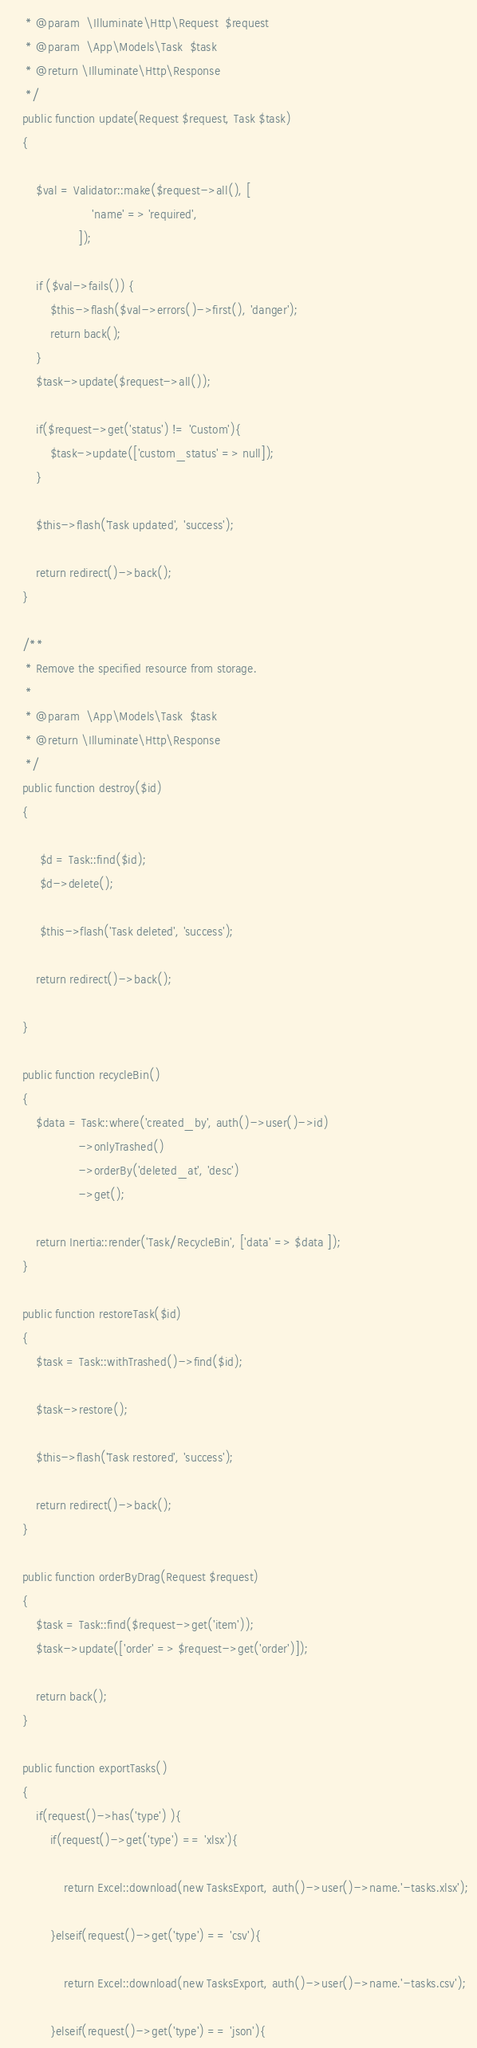Convert code to text. <code><loc_0><loc_0><loc_500><loc_500><_PHP_>     * @param  \Illuminate\Http\Request  $request
     * @param  \App\Models\Task  $task
     * @return \Illuminate\Http\Response
     */
    public function update(Request $request, Task $task)
    {

        $val = Validator::make($request->all(), [
                        'name' => 'required',
                    ]);

        if ($val->fails()) {
            $this->flash($val->errors()->first(), 'danger');
            return back();
        }
        $task->update($request->all());

        if($request->get('status') != 'Custom'){
            $task->update(['custom_status' => null]);
        }

        $this->flash('Task updated', 'success');

        return redirect()->back();
    }

    /**
     * Remove the specified resource from storage.
     *
     * @param  \App\Models\Task  $task
     * @return \Illuminate\Http\Response
     */
    public function destroy($id)
    {

         $d = Task::find($id);
         $d->delete();

         $this->flash('Task deleted', 'success');

        return redirect()->back();

    }

    public function recycleBin()
    {
        $data = Task::where('created_by', auth()->user()->id)
                    ->onlyTrashed()
                    ->orderBy('deleted_at', 'desc')
                    ->get();

        return Inertia::render('Task/RecycleBin', ['data' => $data ]);
    }

    public function restoreTask($id)
    {
        $task = Task::withTrashed()->find($id);

        $task->restore();

        $this->flash('Task restored', 'success');

        return redirect()->back();
    }

    public function orderByDrag(Request $request)
    {
        $task = Task::find($request->get('item'));
        $task->update(['order' => $request->get('order')]);

        return back();
    }

    public function exportTasks()
    {
        if(request()->has('type') ){
            if(request()->get('type') == 'xlsx'){

                return Excel::download(new TasksExport, auth()->user()->name.'-tasks.xlsx');

            }elseif(request()->get('type') == 'csv'){

                return Excel::download(new TasksExport, auth()->user()->name.'-tasks.csv');

            }elseif(request()->get('type') == 'json'){
</code> 